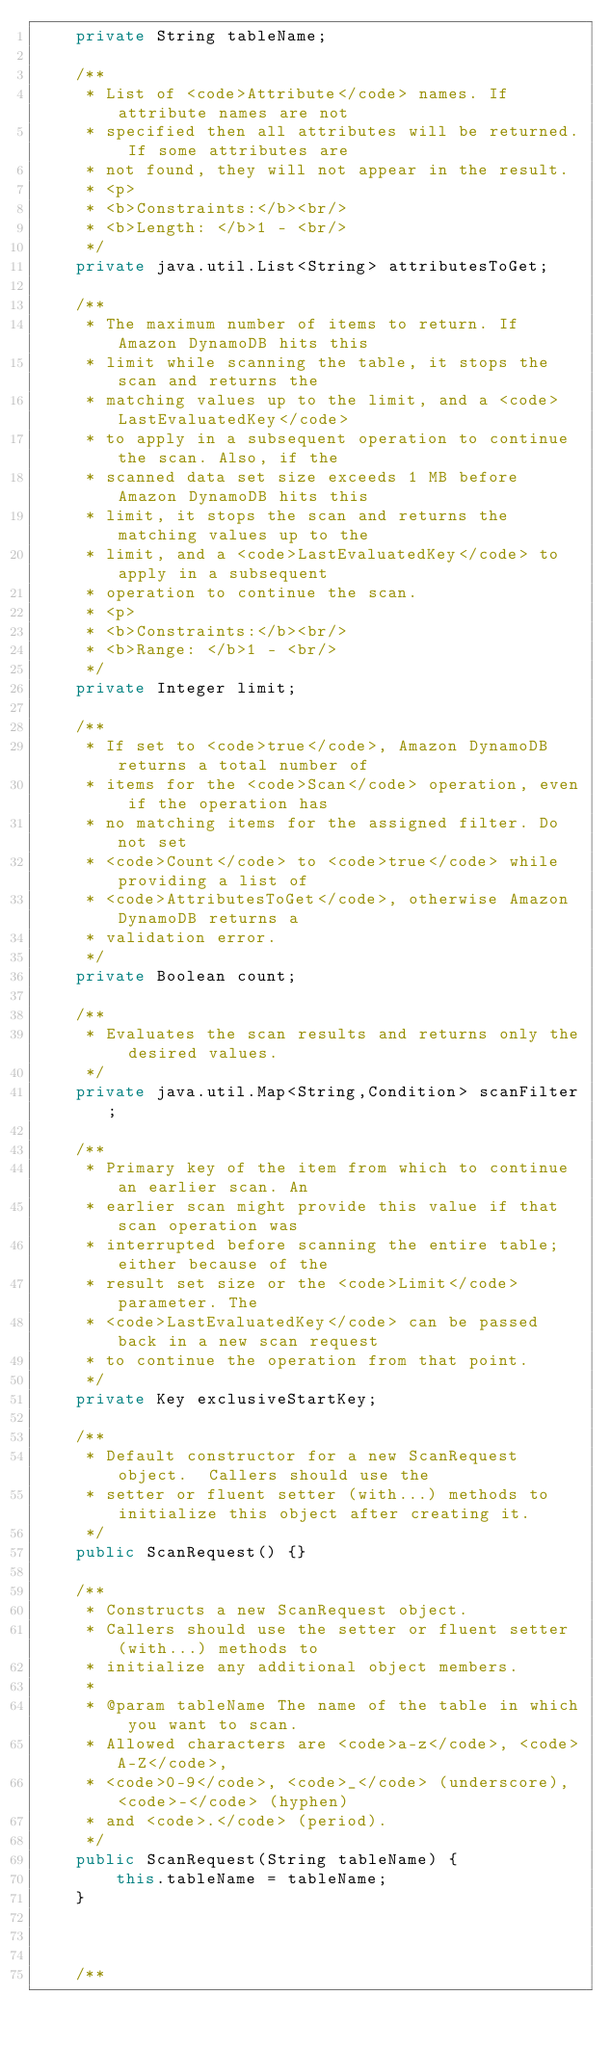<code> <loc_0><loc_0><loc_500><loc_500><_Java_>    private String tableName;

    /**
     * List of <code>Attribute</code> names. If attribute names are not
     * specified then all attributes will be returned. If some attributes are
     * not found, they will not appear in the result.
     * <p>
     * <b>Constraints:</b><br/>
     * <b>Length: </b>1 - <br/>
     */
    private java.util.List<String> attributesToGet;

    /**
     * The maximum number of items to return. If Amazon DynamoDB hits this
     * limit while scanning the table, it stops the scan and returns the
     * matching values up to the limit, and a <code>LastEvaluatedKey</code>
     * to apply in a subsequent operation to continue the scan. Also, if the
     * scanned data set size exceeds 1 MB before Amazon DynamoDB hits this
     * limit, it stops the scan and returns the matching values up to the
     * limit, and a <code>LastEvaluatedKey</code> to apply in a subsequent
     * operation to continue the scan.
     * <p>
     * <b>Constraints:</b><br/>
     * <b>Range: </b>1 - <br/>
     */
    private Integer limit;

    /**
     * If set to <code>true</code>, Amazon DynamoDB returns a total number of
     * items for the <code>Scan</code> operation, even if the operation has
     * no matching items for the assigned filter. Do not set
     * <code>Count</code> to <code>true</code> while providing a list of
     * <code>AttributesToGet</code>, otherwise Amazon DynamoDB returns a
     * validation error.
     */
    private Boolean count;

    /**
     * Evaluates the scan results and returns only the desired values.
     */
    private java.util.Map<String,Condition> scanFilter;

    /**
     * Primary key of the item from which to continue an earlier scan. An
     * earlier scan might provide this value if that scan operation was
     * interrupted before scanning the entire table; either because of the
     * result set size or the <code>Limit</code> parameter. The
     * <code>LastEvaluatedKey</code> can be passed back in a new scan request
     * to continue the operation from that point.
     */
    private Key exclusiveStartKey;

    /**
     * Default constructor for a new ScanRequest object.  Callers should use the
     * setter or fluent setter (with...) methods to initialize this object after creating it.
     */
    public ScanRequest() {}
    
    /**
     * Constructs a new ScanRequest object.
     * Callers should use the setter or fluent setter (with...) methods to
     * initialize any additional object members.
     * 
     * @param tableName The name of the table in which you want to scan.
     * Allowed characters are <code>a-z</code>, <code>A-Z</code>,
     * <code>0-9</code>, <code>_</code> (underscore), <code>-</code> (hyphen)
     * and <code>.</code> (period).
     */
    public ScanRequest(String tableName) {
        this.tableName = tableName;
    }

    
    
    /**</code> 